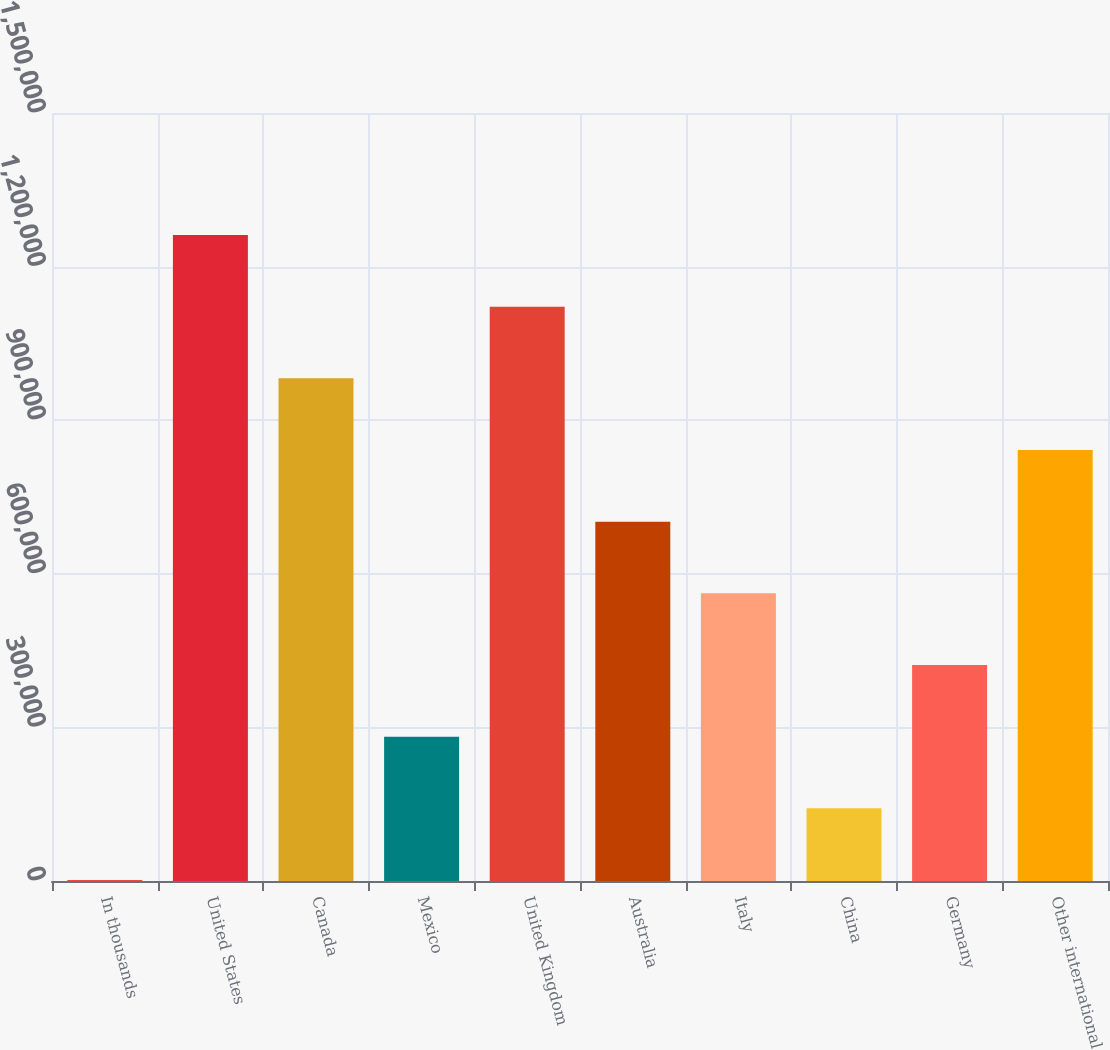Convert chart. <chart><loc_0><loc_0><loc_500><loc_500><bar_chart><fcel>In thousands<fcel>United States<fcel>Canada<fcel>Mexico<fcel>United Kingdom<fcel>Australia<fcel>Italy<fcel>China<fcel>Germany<fcel>Other international<nl><fcel>2009<fcel>1.26166e+06<fcel>981734<fcel>281930<fcel>1.12169e+06<fcel>701812<fcel>561852<fcel>141970<fcel>421891<fcel>841773<nl></chart> 